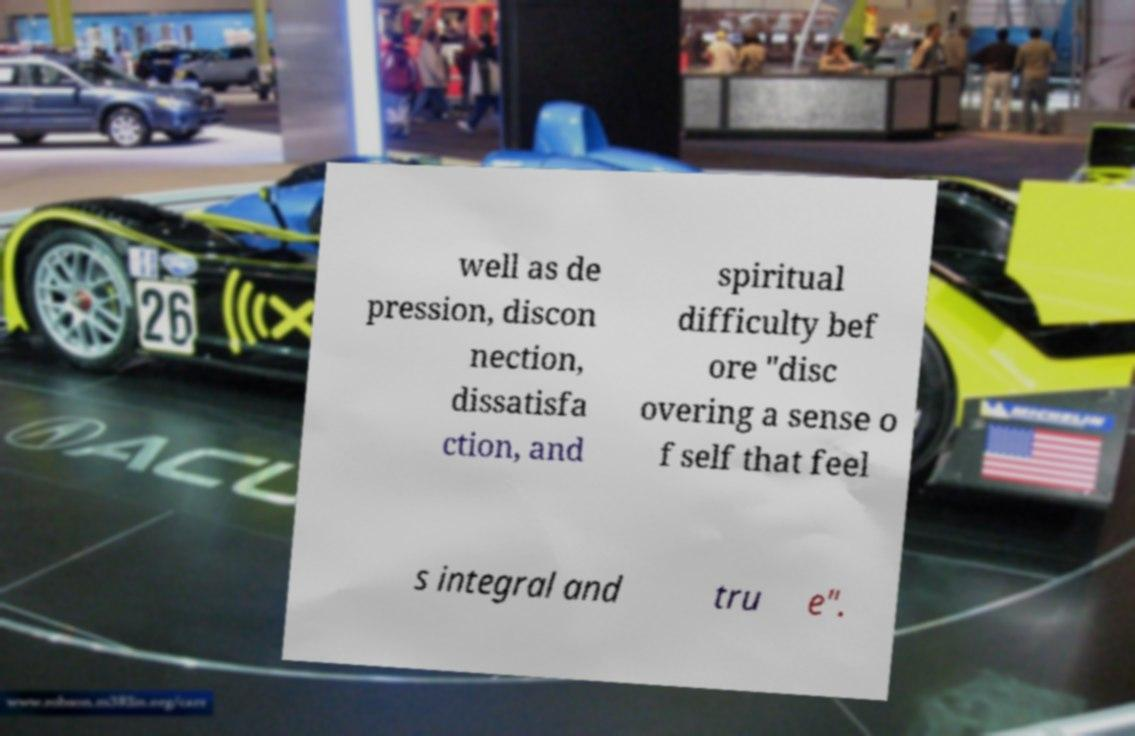Please identify and transcribe the text found in this image. well as de pression, discon nection, dissatisfa ction, and spiritual difficulty bef ore "disc overing a sense o f self that feel s integral and tru e". 